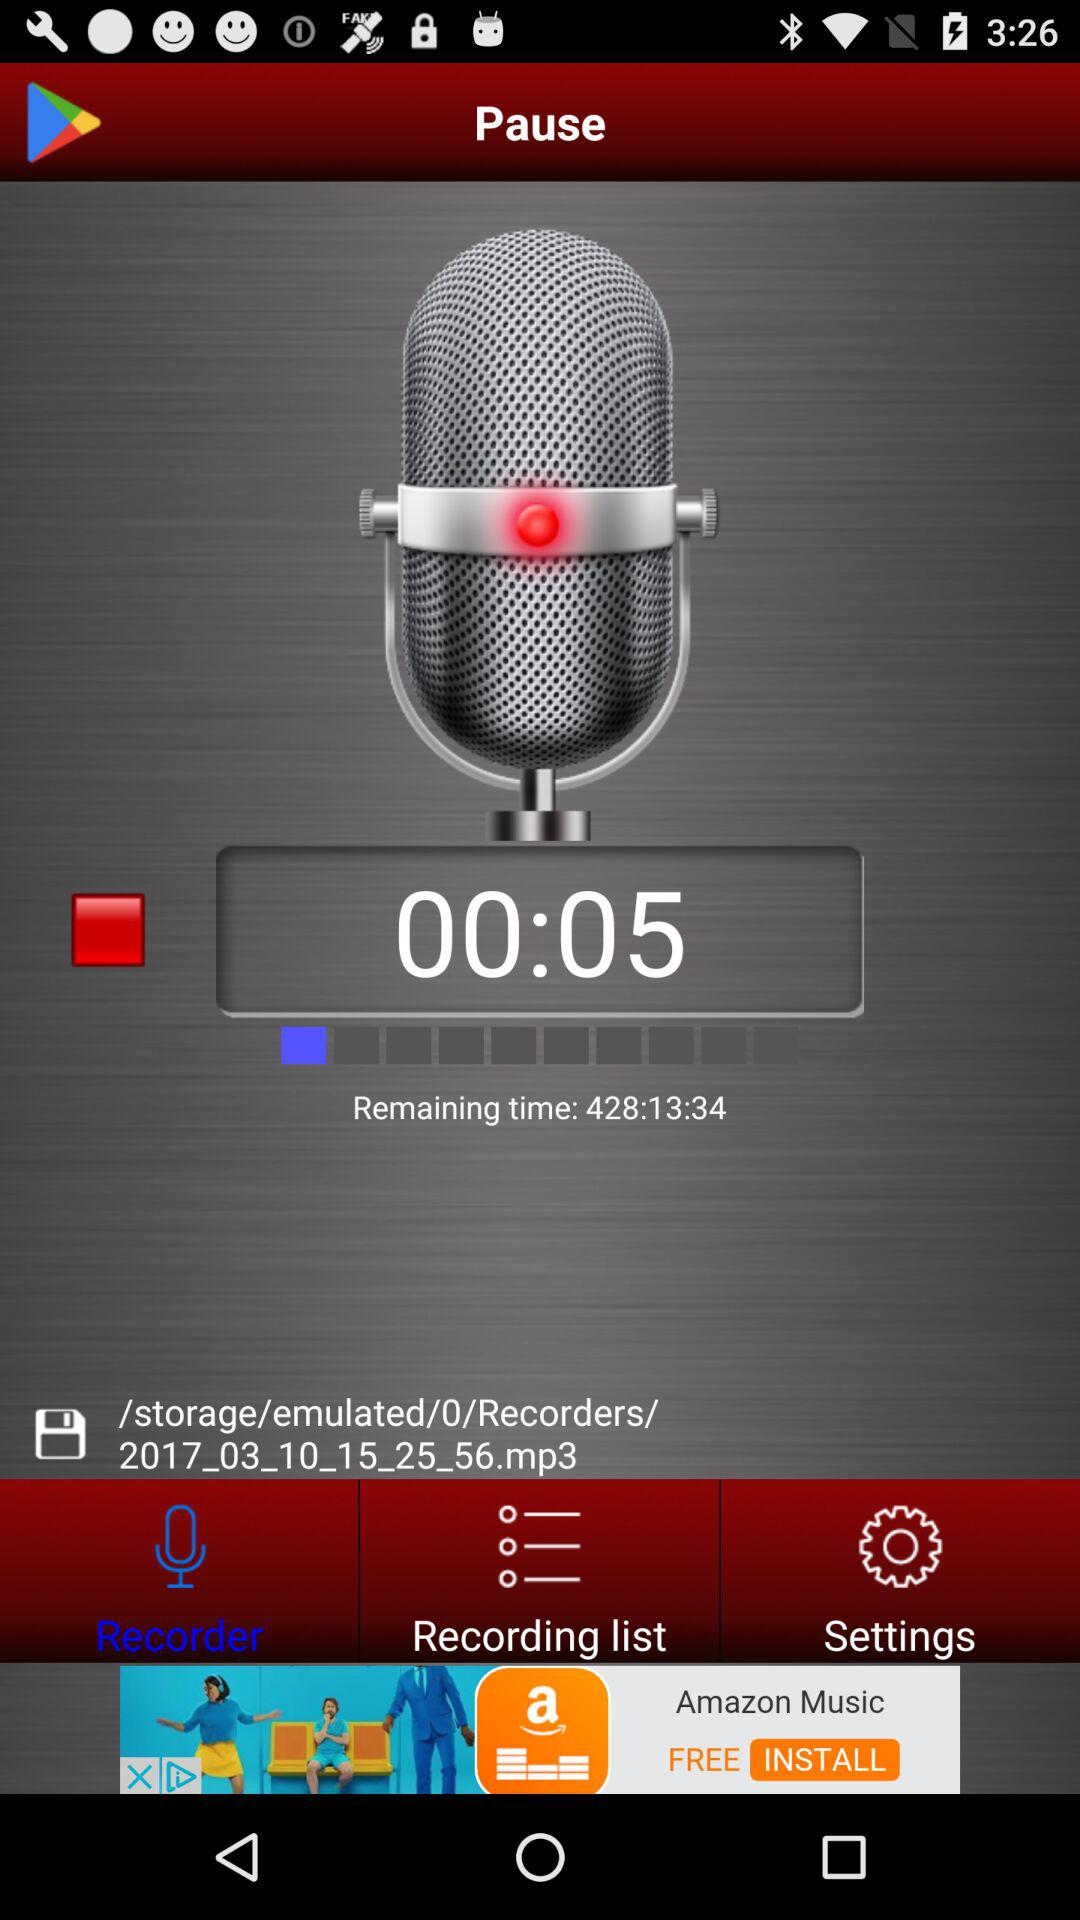How long is the recording?
Answer the question using a single word or phrase. 00:05 